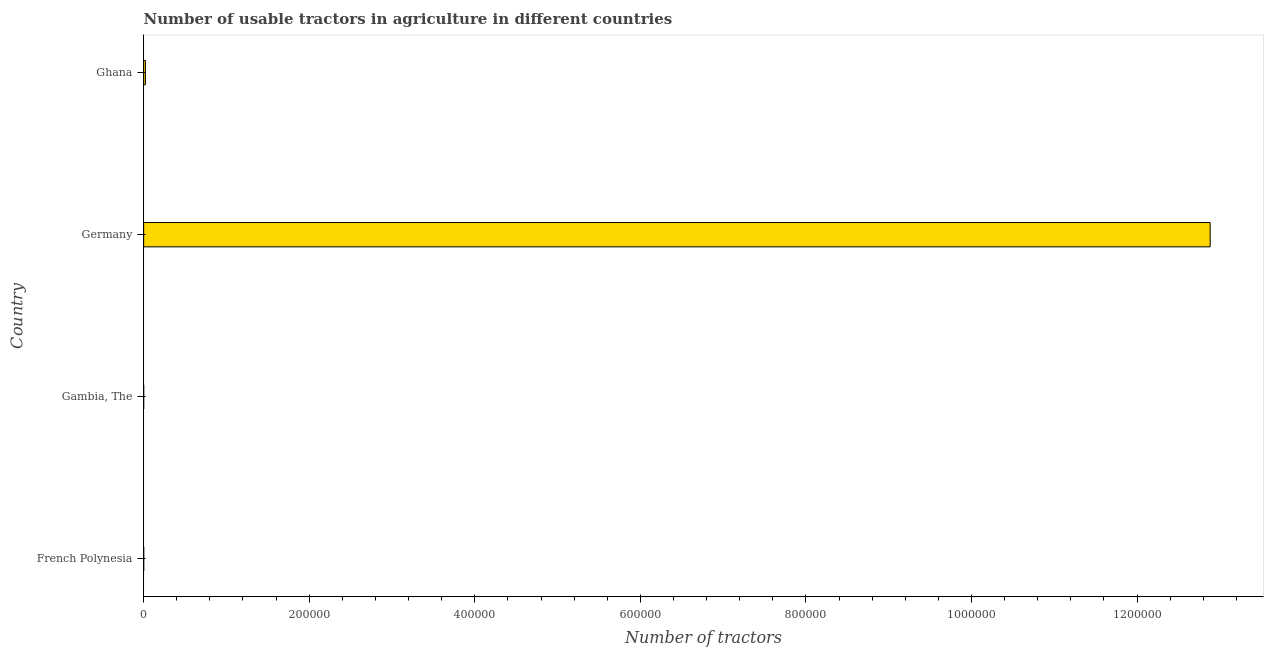Does the graph contain grids?
Provide a succinct answer. No. What is the title of the graph?
Your answer should be very brief. Number of usable tractors in agriculture in different countries. What is the label or title of the X-axis?
Your answer should be compact. Number of tractors. What is the number of tractors in Germany?
Keep it short and to the point. 1.29e+06. Across all countries, what is the maximum number of tractors?
Your response must be concise. 1.29e+06. Across all countries, what is the minimum number of tractors?
Ensure brevity in your answer.  43. In which country was the number of tractors minimum?
Offer a terse response. Gambia, The. What is the sum of the number of tractors?
Ensure brevity in your answer.  1.29e+06. What is the average number of tractors per country?
Keep it short and to the point. 3.23e+05. What is the median number of tractors?
Give a very brief answer. 1102. What is the difference between the highest and the second highest number of tractors?
Ensure brevity in your answer.  1.29e+06. What is the difference between the highest and the lowest number of tractors?
Offer a very short reply. 1.29e+06. How many bars are there?
Provide a short and direct response. 4. Are all the bars in the graph horizontal?
Offer a terse response. Yes. What is the difference between two consecutive major ticks on the X-axis?
Make the answer very short. 2.00e+05. Are the values on the major ticks of X-axis written in scientific E-notation?
Provide a succinct answer. No. What is the Number of tractors of Gambia, The?
Ensure brevity in your answer.  43. What is the Number of tractors of Germany?
Give a very brief answer. 1.29e+06. What is the Number of tractors of Ghana?
Ensure brevity in your answer.  2124. What is the difference between the Number of tractors in French Polynesia and Gambia, The?
Your response must be concise. 37. What is the difference between the Number of tractors in French Polynesia and Germany?
Your answer should be very brief. -1.29e+06. What is the difference between the Number of tractors in French Polynesia and Ghana?
Offer a very short reply. -2044. What is the difference between the Number of tractors in Gambia, The and Germany?
Your answer should be compact. -1.29e+06. What is the difference between the Number of tractors in Gambia, The and Ghana?
Offer a terse response. -2081. What is the difference between the Number of tractors in Germany and Ghana?
Offer a terse response. 1.29e+06. What is the ratio of the Number of tractors in French Polynesia to that in Gambia, The?
Ensure brevity in your answer.  1.86. What is the ratio of the Number of tractors in French Polynesia to that in Germany?
Your response must be concise. 0. What is the ratio of the Number of tractors in French Polynesia to that in Ghana?
Ensure brevity in your answer.  0.04. What is the ratio of the Number of tractors in Gambia, The to that in Germany?
Your answer should be compact. 0. What is the ratio of the Number of tractors in Gambia, The to that in Ghana?
Provide a succinct answer. 0.02. What is the ratio of the Number of tractors in Germany to that in Ghana?
Give a very brief answer. 606.58. 